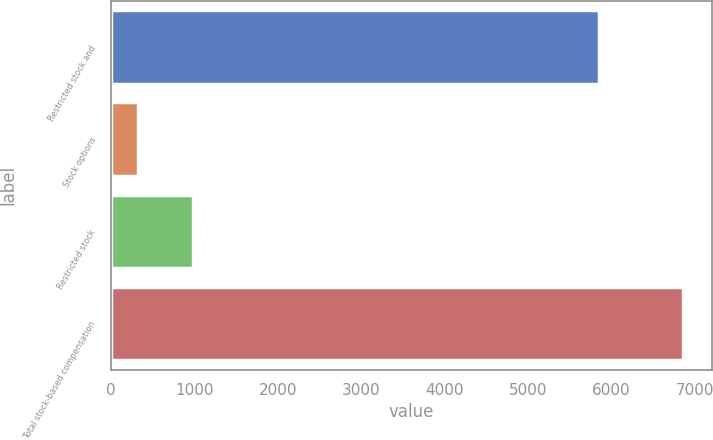Convert chart. <chart><loc_0><loc_0><loc_500><loc_500><bar_chart><fcel>Restricted stock and<fcel>Stock options<fcel>Restricted stock<fcel>Total stock-based compensation<nl><fcel>5856<fcel>324<fcel>977.5<fcel>6859<nl></chart> 